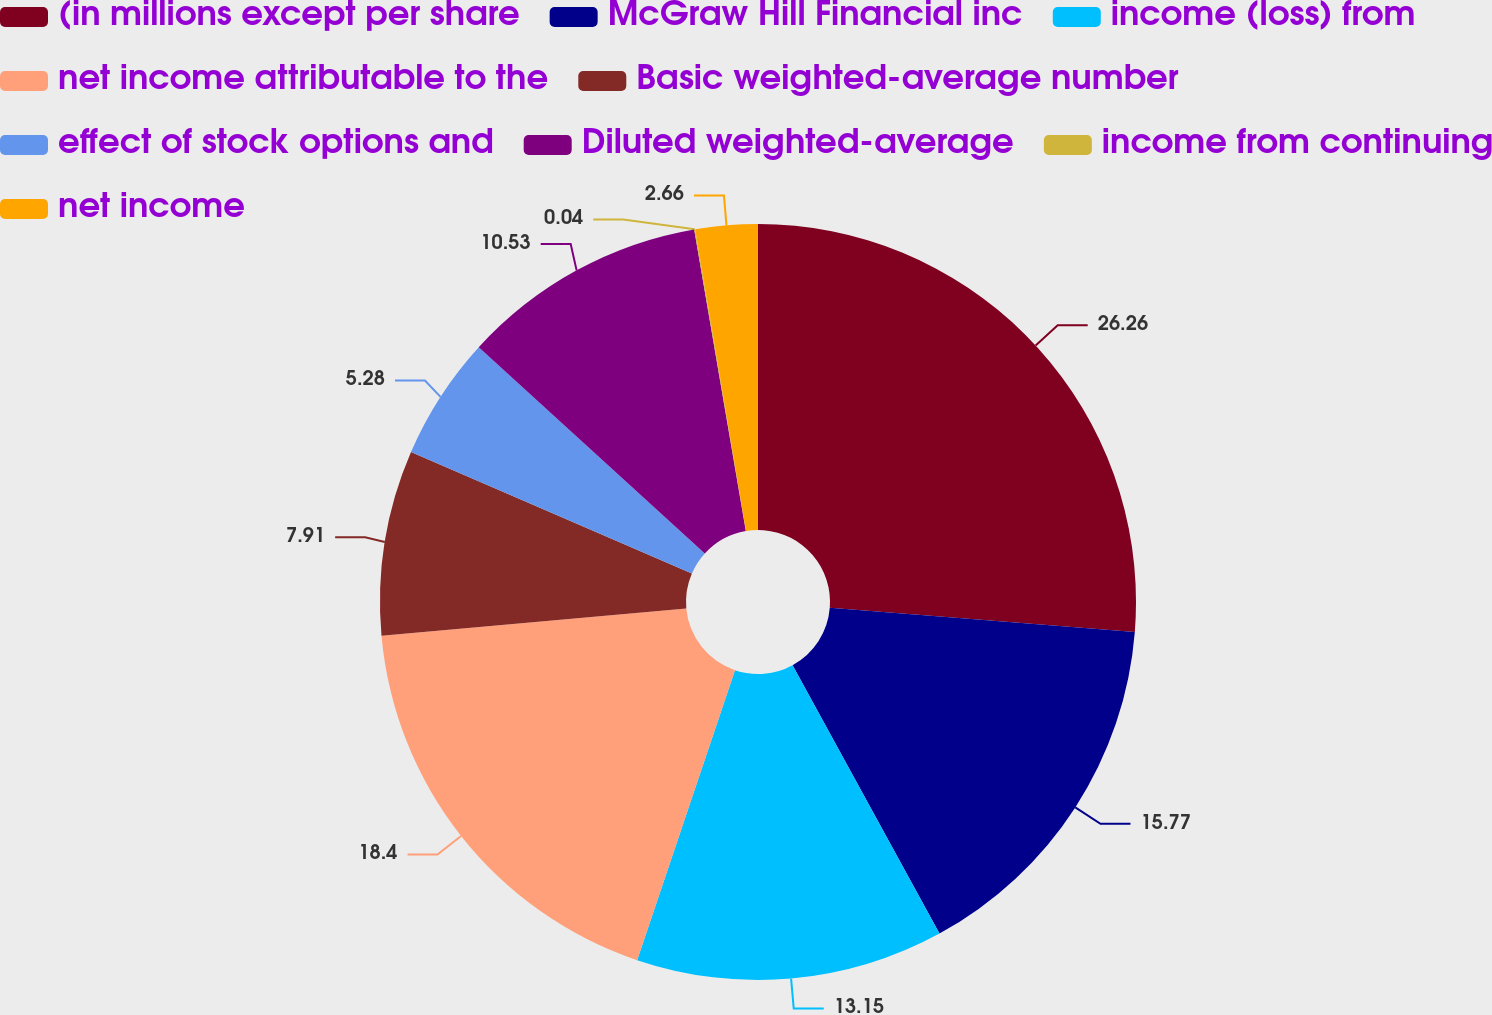<chart> <loc_0><loc_0><loc_500><loc_500><pie_chart><fcel>(in millions except per share<fcel>McGraw Hill Financial inc<fcel>income (loss) from<fcel>net income attributable to the<fcel>Basic weighted-average number<fcel>effect of stock options and<fcel>Diluted weighted-average<fcel>income from continuing<fcel>net income<nl><fcel>26.26%<fcel>15.77%<fcel>13.15%<fcel>18.4%<fcel>7.91%<fcel>5.28%<fcel>10.53%<fcel>0.04%<fcel>2.66%<nl></chart> 